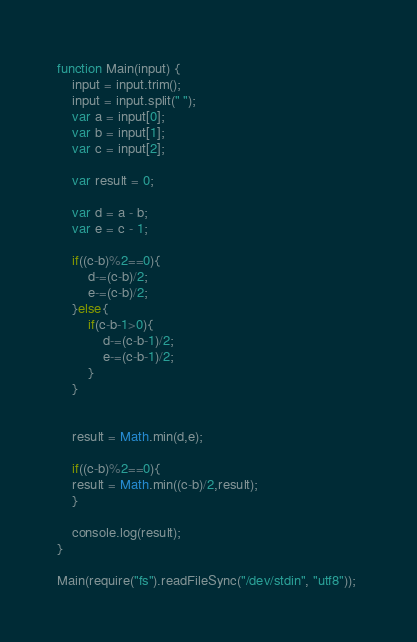Convert code to text. <code><loc_0><loc_0><loc_500><loc_500><_JavaScript_>function Main(input) {
    input = input.trim();
    input = input.split(" ");
    var a = input[0];
    var b = input[1];
    var c = input[2];

    var result = 0;

    var d = a - b;
    var e = c - 1;

    if((c-b)%2==0){        
        d-=(c-b)/2;
        e-=(c-b)/2;
    }else{
        if(c-b-1>0){
            d-=(c-b-1)/2;
            e-=(c-b-1)/2;
        }
    }
    

    result = Math.min(d,e);

    if((c-b)%2==0){ 
    result = Math.min((c-b)/2,result);    
    }

    console.log(result);
}

Main(require("fs").readFileSync("/dev/stdin", "utf8")); </code> 